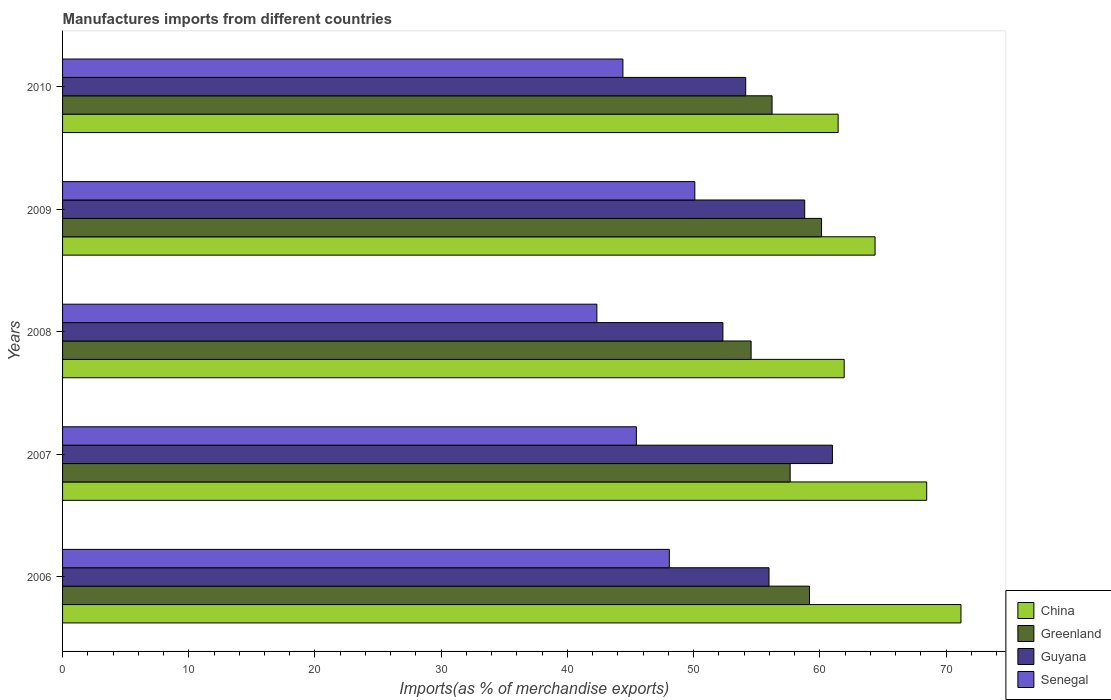How many groups of bars are there?
Keep it short and to the point. 5. Are the number of bars per tick equal to the number of legend labels?
Your answer should be compact. Yes. Are the number of bars on each tick of the Y-axis equal?
Offer a terse response. Yes. How many bars are there on the 5th tick from the top?
Keep it short and to the point. 4. How many bars are there on the 4th tick from the bottom?
Provide a succinct answer. 4. What is the percentage of imports to different countries in Greenland in 2010?
Provide a short and direct response. 56.22. Across all years, what is the maximum percentage of imports to different countries in China?
Your response must be concise. 71.18. Across all years, what is the minimum percentage of imports to different countries in Greenland?
Make the answer very short. 54.56. In which year was the percentage of imports to different countries in Senegal maximum?
Offer a very short reply. 2009. In which year was the percentage of imports to different countries in Greenland minimum?
Your response must be concise. 2008. What is the total percentage of imports to different countries in China in the graph?
Keep it short and to the point. 327.41. What is the difference between the percentage of imports to different countries in Senegal in 2007 and that in 2008?
Offer a terse response. 3.13. What is the difference between the percentage of imports to different countries in Senegal in 2006 and the percentage of imports to different countries in Greenland in 2007?
Provide a succinct answer. -9.57. What is the average percentage of imports to different countries in Guyana per year?
Offer a very short reply. 56.45. In the year 2008, what is the difference between the percentage of imports to different countries in Senegal and percentage of imports to different countries in China?
Your answer should be very brief. -19.6. In how many years, is the percentage of imports to different countries in China greater than 68 %?
Your response must be concise. 2. What is the ratio of the percentage of imports to different countries in Guyana in 2007 to that in 2009?
Your answer should be compact. 1.04. What is the difference between the highest and the second highest percentage of imports to different countries in Guyana?
Provide a succinct answer. 2.2. What is the difference between the highest and the lowest percentage of imports to different countries in China?
Provide a short and direct response. 9.73. In how many years, is the percentage of imports to different countries in Guyana greater than the average percentage of imports to different countries in Guyana taken over all years?
Your response must be concise. 2. Is it the case that in every year, the sum of the percentage of imports to different countries in Senegal and percentage of imports to different countries in China is greater than the sum of percentage of imports to different countries in Greenland and percentage of imports to different countries in Guyana?
Your answer should be compact. No. What does the 3rd bar from the bottom in 2009 represents?
Provide a succinct answer. Guyana. Are all the bars in the graph horizontal?
Your response must be concise. Yes. Does the graph contain any zero values?
Offer a terse response. No. Does the graph contain grids?
Offer a terse response. No. Where does the legend appear in the graph?
Your response must be concise. Bottom right. How many legend labels are there?
Provide a short and direct response. 4. How are the legend labels stacked?
Offer a very short reply. Vertical. What is the title of the graph?
Give a very brief answer. Manufactures imports from different countries. What is the label or title of the X-axis?
Keep it short and to the point. Imports(as % of merchandise exports). What is the Imports(as % of merchandise exports) of China in 2006?
Provide a succinct answer. 71.18. What is the Imports(as % of merchandise exports) of Greenland in 2006?
Keep it short and to the point. 59.18. What is the Imports(as % of merchandise exports) of Guyana in 2006?
Provide a succinct answer. 55.98. What is the Imports(as % of merchandise exports) in Senegal in 2006?
Offer a terse response. 48.08. What is the Imports(as % of merchandise exports) of China in 2007?
Your answer should be compact. 68.47. What is the Imports(as % of merchandise exports) in Greenland in 2007?
Your answer should be compact. 57.65. What is the Imports(as % of merchandise exports) of Guyana in 2007?
Make the answer very short. 61. What is the Imports(as % of merchandise exports) in Senegal in 2007?
Keep it short and to the point. 45.47. What is the Imports(as % of merchandise exports) of China in 2008?
Provide a short and direct response. 61.93. What is the Imports(as % of merchandise exports) of Greenland in 2008?
Provide a short and direct response. 54.56. What is the Imports(as % of merchandise exports) of Guyana in 2008?
Your answer should be very brief. 52.32. What is the Imports(as % of merchandise exports) of Senegal in 2008?
Your answer should be compact. 42.33. What is the Imports(as % of merchandise exports) in China in 2009?
Your response must be concise. 64.38. What is the Imports(as % of merchandise exports) of Greenland in 2009?
Provide a succinct answer. 60.14. What is the Imports(as % of merchandise exports) of Guyana in 2009?
Your response must be concise. 58.8. What is the Imports(as % of merchandise exports) in Senegal in 2009?
Provide a succinct answer. 50.1. What is the Imports(as % of merchandise exports) in China in 2010?
Your answer should be very brief. 61.45. What is the Imports(as % of merchandise exports) in Greenland in 2010?
Provide a short and direct response. 56.22. What is the Imports(as % of merchandise exports) in Guyana in 2010?
Ensure brevity in your answer.  54.13. What is the Imports(as % of merchandise exports) in Senegal in 2010?
Give a very brief answer. 44.4. Across all years, what is the maximum Imports(as % of merchandise exports) of China?
Ensure brevity in your answer.  71.18. Across all years, what is the maximum Imports(as % of merchandise exports) of Greenland?
Keep it short and to the point. 60.14. Across all years, what is the maximum Imports(as % of merchandise exports) in Guyana?
Offer a very short reply. 61. Across all years, what is the maximum Imports(as % of merchandise exports) of Senegal?
Your response must be concise. 50.1. Across all years, what is the minimum Imports(as % of merchandise exports) of China?
Your answer should be very brief. 61.45. Across all years, what is the minimum Imports(as % of merchandise exports) in Greenland?
Your answer should be very brief. 54.56. Across all years, what is the minimum Imports(as % of merchandise exports) of Guyana?
Keep it short and to the point. 52.32. Across all years, what is the minimum Imports(as % of merchandise exports) in Senegal?
Your answer should be very brief. 42.33. What is the total Imports(as % of merchandise exports) of China in the graph?
Offer a terse response. 327.41. What is the total Imports(as % of merchandise exports) in Greenland in the graph?
Offer a terse response. 287.74. What is the total Imports(as % of merchandise exports) of Guyana in the graph?
Ensure brevity in your answer.  282.23. What is the total Imports(as % of merchandise exports) of Senegal in the graph?
Provide a short and direct response. 230.37. What is the difference between the Imports(as % of merchandise exports) of China in 2006 and that in 2007?
Keep it short and to the point. 2.71. What is the difference between the Imports(as % of merchandise exports) in Greenland in 2006 and that in 2007?
Offer a very short reply. 1.53. What is the difference between the Imports(as % of merchandise exports) of Guyana in 2006 and that in 2007?
Offer a very short reply. -5.02. What is the difference between the Imports(as % of merchandise exports) of Senegal in 2006 and that in 2007?
Your response must be concise. 2.61. What is the difference between the Imports(as % of merchandise exports) of China in 2006 and that in 2008?
Give a very brief answer. 9.25. What is the difference between the Imports(as % of merchandise exports) in Greenland in 2006 and that in 2008?
Give a very brief answer. 4.63. What is the difference between the Imports(as % of merchandise exports) in Guyana in 2006 and that in 2008?
Your answer should be compact. 3.65. What is the difference between the Imports(as % of merchandise exports) of Senegal in 2006 and that in 2008?
Give a very brief answer. 5.74. What is the difference between the Imports(as % of merchandise exports) of China in 2006 and that in 2009?
Offer a very short reply. 6.81. What is the difference between the Imports(as % of merchandise exports) in Greenland in 2006 and that in 2009?
Your answer should be very brief. -0.95. What is the difference between the Imports(as % of merchandise exports) in Guyana in 2006 and that in 2009?
Offer a very short reply. -2.83. What is the difference between the Imports(as % of merchandise exports) in Senegal in 2006 and that in 2009?
Provide a succinct answer. -2.02. What is the difference between the Imports(as % of merchandise exports) in China in 2006 and that in 2010?
Offer a very short reply. 9.73. What is the difference between the Imports(as % of merchandise exports) of Greenland in 2006 and that in 2010?
Make the answer very short. 2.97. What is the difference between the Imports(as % of merchandise exports) of Guyana in 2006 and that in 2010?
Offer a very short reply. 1.85. What is the difference between the Imports(as % of merchandise exports) of Senegal in 2006 and that in 2010?
Your answer should be very brief. 3.68. What is the difference between the Imports(as % of merchandise exports) in China in 2007 and that in 2008?
Your answer should be very brief. 6.54. What is the difference between the Imports(as % of merchandise exports) in Greenland in 2007 and that in 2008?
Keep it short and to the point. 3.09. What is the difference between the Imports(as % of merchandise exports) in Guyana in 2007 and that in 2008?
Keep it short and to the point. 8.68. What is the difference between the Imports(as % of merchandise exports) in Senegal in 2007 and that in 2008?
Offer a very short reply. 3.13. What is the difference between the Imports(as % of merchandise exports) in China in 2007 and that in 2009?
Ensure brevity in your answer.  4.09. What is the difference between the Imports(as % of merchandise exports) of Greenland in 2007 and that in 2009?
Offer a terse response. -2.49. What is the difference between the Imports(as % of merchandise exports) in Guyana in 2007 and that in 2009?
Give a very brief answer. 2.2. What is the difference between the Imports(as % of merchandise exports) of Senegal in 2007 and that in 2009?
Offer a very short reply. -4.63. What is the difference between the Imports(as % of merchandise exports) of China in 2007 and that in 2010?
Your answer should be compact. 7.02. What is the difference between the Imports(as % of merchandise exports) of Greenland in 2007 and that in 2010?
Your response must be concise. 1.43. What is the difference between the Imports(as % of merchandise exports) in Guyana in 2007 and that in 2010?
Make the answer very short. 6.87. What is the difference between the Imports(as % of merchandise exports) in Senegal in 2007 and that in 2010?
Keep it short and to the point. 1.07. What is the difference between the Imports(as % of merchandise exports) of China in 2008 and that in 2009?
Give a very brief answer. -2.45. What is the difference between the Imports(as % of merchandise exports) in Greenland in 2008 and that in 2009?
Ensure brevity in your answer.  -5.58. What is the difference between the Imports(as % of merchandise exports) in Guyana in 2008 and that in 2009?
Make the answer very short. -6.48. What is the difference between the Imports(as % of merchandise exports) in Senegal in 2008 and that in 2009?
Provide a short and direct response. -7.76. What is the difference between the Imports(as % of merchandise exports) in China in 2008 and that in 2010?
Provide a succinct answer. 0.48. What is the difference between the Imports(as % of merchandise exports) in Greenland in 2008 and that in 2010?
Make the answer very short. -1.66. What is the difference between the Imports(as % of merchandise exports) in Guyana in 2008 and that in 2010?
Ensure brevity in your answer.  -1.81. What is the difference between the Imports(as % of merchandise exports) of Senegal in 2008 and that in 2010?
Your answer should be compact. -2.06. What is the difference between the Imports(as % of merchandise exports) of China in 2009 and that in 2010?
Provide a short and direct response. 2.93. What is the difference between the Imports(as % of merchandise exports) of Greenland in 2009 and that in 2010?
Offer a very short reply. 3.92. What is the difference between the Imports(as % of merchandise exports) in Guyana in 2009 and that in 2010?
Provide a succinct answer. 4.67. What is the difference between the Imports(as % of merchandise exports) in Senegal in 2009 and that in 2010?
Ensure brevity in your answer.  5.7. What is the difference between the Imports(as % of merchandise exports) of China in 2006 and the Imports(as % of merchandise exports) of Greenland in 2007?
Your response must be concise. 13.53. What is the difference between the Imports(as % of merchandise exports) in China in 2006 and the Imports(as % of merchandise exports) in Guyana in 2007?
Keep it short and to the point. 10.18. What is the difference between the Imports(as % of merchandise exports) of China in 2006 and the Imports(as % of merchandise exports) of Senegal in 2007?
Your answer should be very brief. 25.72. What is the difference between the Imports(as % of merchandise exports) in Greenland in 2006 and the Imports(as % of merchandise exports) in Guyana in 2007?
Your response must be concise. -1.82. What is the difference between the Imports(as % of merchandise exports) of Greenland in 2006 and the Imports(as % of merchandise exports) of Senegal in 2007?
Provide a succinct answer. 13.72. What is the difference between the Imports(as % of merchandise exports) in Guyana in 2006 and the Imports(as % of merchandise exports) in Senegal in 2007?
Your answer should be compact. 10.51. What is the difference between the Imports(as % of merchandise exports) of China in 2006 and the Imports(as % of merchandise exports) of Greenland in 2008?
Provide a succinct answer. 16.63. What is the difference between the Imports(as % of merchandise exports) in China in 2006 and the Imports(as % of merchandise exports) in Guyana in 2008?
Your answer should be very brief. 18.86. What is the difference between the Imports(as % of merchandise exports) in China in 2006 and the Imports(as % of merchandise exports) in Senegal in 2008?
Offer a very short reply. 28.85. What is the difference between the Imports(as % of merchandise exports) of Greenland in 2006 and the Imports(as % of merchandise exports) of Guyana in 2008?
Your response must be concise. 6.86. What is the difference between the Imports(as % of merchandise exports) in Greenland in 2006 and the Imports(as % of merchandise exports) in Senegal in 2008?
Your response must be concise. 16.85. What is the difference between the Imports(as % of merchandise exports) in Guyana in 2006 and the Imports(as % of merchandise exports) in Senegal in 2008?
Ensure brevity in your answer.  13.64. What is the difference between the Imports(as % of merchandise exports) of China in 2006 and the Imports(as % of merchandise exports) of Greenland in 2009?
Offer a very short reply. 11.05. What is the difference between the Imports(as % of merchandise exports) of China in 2006 and the Imports(as % of merchandise exports) of Guyana in 2009?
Offer a terse response. 12.38. What is the difference between the Imports(as % of merchandise exports) in China in 2006 and the Imports(as % of merchandise exports) in Senegal in 2009?
Your response must be concise. 21.09. What is the difference between the Imports(as % of merchandise exports) in Greenland in 2006 and the Imports(as % of merchandise exports) in Guyana in 2009?
Your answer should be compact. 0.38. What is the difference between the Imports(as % of merchandise exports) in Greenland in 2006 and the Imports(as % of merchandise exports) in Senegal in 2009?
Offer a terse response. 9.09. What is the difference between the Imports(as % of merchandise exports) of Guyana in 2006 and the Imports(as % of merchandise exports) of Senegal in 2009?
Provide a short and direct response. 5.88. What is the difference between the Imports(as % of merchandise exports) of China in 2006 and the Imports(as % of merchandise exports) of Greenland in 2010?
Provide a short and direct response. 14.97. What is the difference between the Imports(as % of merchandise exports) in China in 2006 and the Imports(as % of merchandise exports) in Guyana in 2010?
Offer a terse response. 17.05. What is the difference between the Imports(as % of merchandise exports) in China in 2006 and the Imports(as % of merchandise exports) in Senegal in 2010?
Provide a short and direct response. 26.78. What is the difference between the Imports(as % of merchandise exports) of Greenland in 2006 and the Imports(as % of merchandise exports) of Guyana in 2010?
Make the answer very short. 5.05. What is the difference between the Imports(as % of merchandise exports) of Greenland in 2006 and the Imports(as % of merchandise exports) of Senegal in 2010?
Offer a very short reply. 14.78. What is the difference between the Imports(as % of merchandise exports) in Guyana in 2006 and the Imports(as % of merchandise exports) in Senegal in 2010?
Your response must be concise. 11.58. What is the difference between the Imports(as % of merchandise exports) in China in 2007 and the Imports(as % of merchandise exports) in Greenland in 2008?
Provide a short and direct response. 13.91. What is the difference between the Imports(as % of merchandise exports) of China in 2007 and the Imports(as % of merchandise exports) of Guyana in 2008?
Give a very brief answer. 16.15. What is the difference between the Imports(as % of merchandise exports) in China in 2007 and the Imports(as % of merchandise exports) in Senegal in 2008?
Provide a succinct answer. 26.13. What is the difference between the Imports(as % of merchandise exports) of Greenland in 2007 and the Imports(as % of merchandise exports) of Guyana in 2008?
Provide a short and direct response. 5.33. What is the difference between the Imports(as % of merchandise exports) of Greenland in 2007 and the Imports(as % of merchandise exports) of Senegal in 2008?
Keep it short and to the point. 15.32. What is the difference between the Imports(as % of merchandise exports) in Guyana in 2007 and the Imports(as % of merchandise exports) in Senegal in 2008?
Your answer should be very brief. 18.66. What is the difference between the Imports(as % of merchandise exports) of China in 2007 and the Imports(as % of merchandise exports) of Greenland in 2009?
Keep it short and to the point. 8.33. What is the difference between the Imports(as % of merchandise exports) in China in 2007 and the Imports(as % of merchandise exports) in Guyana in 2009?
Your response must be concise. 9.67. What is the difference between the Imports(as % of merchandise exports) of China in 2007 and the Imports(as % of merchandise exports) of Senegal in 2009?
Provide a succinct answer. 18.37. What is the difference between the Imports(as % of merchandise exports) in Greenland in 2007 and the Imports(as % of merchandise exports) in Guyana in 2009?
Provide a succinct answer. -1.15. What is the difference between the Imports(as % of merchandise exports) in Greenland in 2007 and the Imports(as % of merchandise exports) in Senegal in 2009?
Your answer should be compact. 7.55. What is the difference between the Imports(as % of merchandise exports) in Guyana in 2007 and the Imports(as % of merchandise exports) in Senegal in 2009?
Your response must be concise. 10.9. What is the difference between the Imports(as % of merchandise exports) of China in 2007 and the Imports(as % of merchandise exports) of Greenland in 2010?
Your answer should be very brief. 12.25. What is the difference between the Imports(as % of merchandise exports) of China in 2007 and the Imports(as % of merchandise exports) of Guyana in 2010?
Offer a very short reply. 14.34. What is the difference between the Imports(as % of merchandise exports) in China in 2007 and the Imports(as % of merchandise exports) in Senegal in 2010?
Keep it short and to the point. 24.07. What is the difference between the Imports(as % of merchandise exports) of Greenland in 2007 and the Imports(as % of merchandise exports) of Guyana in 2010?
Give a very brief answer. 3.52. What is the difference between the Imports(as % of merchandise exports) of Greenland in 2007 and the Imports(as % of merchandise exports) of Senegal in 2010?
Provide a succinct answer. 13.25. What is the difference between the Imports(as % of merchandise exports) in Guyana in 2007 and the Imports(as % of merchandise exports) in Senegal in 2010?
Offer a terse response. 16.6. What is the difference between the Imports(as % of merchandise exports) of China in 2008 and the Imports(as % of merchandise exports) of Greenland in 2009?
Offer a terse response. 1.79. What is the difference between the Imports(as % of merchandise exports) of China in 2008 and the Imports(as % of merchandise exports) of Guyana in 2009?
Keep it short and to the point. 3.13. What is the difference between the Imports(as % of merchandise exports) in China in 2008 and the Imports(as % of merchandise exports) in Senegal in 2009?
Provide a short and direct response. 11.83. What is the difference between the Imports(as % of merchandise exports) of Greenland in 2008 and the Imports(as % of merchandise exports) of Guyana in 2009?
Offer a very short reply. -4.25. What is the difference between the Imports(as % of merchandise exports) in Greenland in 2008 and the Imports(as % of merchandise exports) in Senegal in 2009?
Offer a very short reply. 4.46. What is the difference between the Imports(as % of merchandise exports) in Guyana in 2008 and the Imports(as % of merchandise exports) in Senegal in 2009?
Give a very brief answer. 2.22. What is the difference between the Imports(as % of merchandise exports) of China in 2008 and the Imports(as % of merchandise exports) of Greenland in 2010?
Provide a short and direct response. 5.71. What is the difference between the Imports(as % of merchandise exports) of China in 2008 and the Imports(as % of merchandise exports) of Guyana in 2010?
Your response must be concise. 7.8. What is the difference between the Imports(as % of merchandise exports) in China in 2008 and the Imports(as % of merchandise exports) in Senegal in 2010?
Offer a terse response. 17.53. What is the difference between the Imports(as % of merchandise exports) in Greenland in 2008 and the Imports(as % of merchandise exports) in Guyana in 2010?
Your answer should be very brief. 0.43. What is the difference between the Imports(as % of merchandise exports) of Greenland in 2008 and the Imports(as % of merchandise exports) of Senegal in 2010?
Your answer should be very brief. 10.16. What is the difference between the Imports(as % of merchandise exports) of Guyana in 2008 and the Imports(as % of merchandise exports) of Senegal in 2010?
Your answer should be compact. 7.92. What is the difference between the Imports(as % of merchandise exports) of China in 2009 and the Imports(as % of merchandise exports) of Greenland in 2010?
Your answer should be compact. 8.16. What is the difference between the Imports(as % of merchandise exports) in China in 2009 and the Imports(as % of merchandise exports) in Guyana in 2010?
Your answer should be very brief. 10.25. What is the difference between the Imports(as % of merchandise exports) of China in 2009 and the Imports(as % of merchandise exports) of Senegal in 2010?
Offer a terse response. 19.98. What is the difference between the Imports(as % of merchandise exports) in Greenland in 2009 and the Imports(as % of merchandise exports) in Guyana in 2010?
Your answer should be very brief. 6.01. What is the difference between the Imports(as % of merchandise exports) of Greenland in 2009 and the Imports(as % of merchandise exports) of Senegal in 2010?
Offer a terse response. 15.74. What is the difference between the Imports(as % of merchandise exports) in Guyana in 2009 and the Imports(as % of merchandise exports) in Senegal in 2010?
Offer a very short reply. 14.4. What is the average Imports(as % of merchandise exports) in China per year?
Keep it short and to the point. 65.48. What is the average Imports(as % of merchandise exports) of Greenland per year?
Give a very brief answer. 57.55. What is the average Imports(as % of merchandise exports) of Guyana per year?
Keep it short and to the point. 56.45. What is the average Imports(as % of merchandise exports) of Senegal per year?
Your answer should be compact. 46.07. In the year 2006, what is the difference between the Imports(as % of merchandise exports) of China and Imports(as % of merchandise exports) of Greenland?
Make the answer very short. 12. In the year 2006, what is the difference between the Imports(as % of merchandise exports) in China and Imports(as % of merchandise exports) in Guyana?
Ensure brevity in your answer.  15.21. In the year 2006, what is the difference between the Imports(as % of merchandise exports) in China and Imports(as % of merchandise exports) in Senegal?
Your answer should be very brief. 23.11. In the year 2006, what is the difference between the Imports(as % of merchandise exports) in Greenland and Imports(as % of merchandise exports) in Guyana?
Give a very brief answer. 3.21. In the year 2006, what is the difference between the Imports(as % of merchandise exports) in Greenland and Imports(as % of merchandise exports) in Senegal?
Give a very brief answer. 11.11. In the year 2006, what is the difference between the Imports(as % of merchandise exports) in Guyana and Imports(as % of merchandise exports) in Senegal?
Give a very brief answer. 7.9. In the year 2007, what is the difference between the Imports(as % of merchandise exports) in China and Imports(as % of merchandise exports) in Greenland?
Give a very brief answer. 10.82. In the year 2007, what is the difference between the Imports(as % of merchandise exports) in China and Imports(as % of merchandise exports) in Guyana?
Give a very brief answer. 7.47. In the year 2007, what is the difference between the Imports(as % of merchandise exports) of China and Imports(as % of merchandise exports) of Senegal?
Give a very brief answer. 23. In the year 2007, what is the difference between the Imports(as % of merchandise exports) in Greenland and Imports(as % of merchandise exports) in Guyana?
Offer a terse response. -3.35. In the year 2007, what is the difference between the Imports(as % of merchandise exports) of Greenland and Imports(as % of merchandise exports) of Senegal?
Your response must be concise. 12.18. In the year 2007, what is the difference between the Imports(as % of merchandise exports) in Guyana and Imports(as % of merchandise exports) in Senegal?
Your answer should be very brief. 15.53. In the year 2008, what is the difference between the Imports(as % of merchandise exports) of China and Imports(as % of merchandise exports) of Greenland?
Make the answer very short. 7.37. In the year 2008, what is the difference between the Imports(as % of merchandise exports) in China and Imports(as % of merchandise exports) in Guyana?
Offer a terse response. 9.61. In the year 2008, what is the difference between the Imports(as % of merchandise exports) of China and Imports(as % of merchandise exports) of Senegal?
Your answer should be compact. 19.6. In the year 2008, what is the difference between the Imports(as % of merchandise exports) in Greenland and Imports(as % of merchandise exports) in Guyana?
Provide a short and direct response. 2.23. In the year 2008, what is the difference between the Imports(as % of merchandise exports) in Greenland and Imports(as % of merchandise exports) in Senegal?
Your response must be concise. 12.22. In the year 2008, what is the difference between the Imports(as % of merchandise exports) of Guyana and Imports(as % of merchandise exports) of Senegal?
Give a very brief answer. 9.99. In the year 2009, what is the difference between the Imports(as % of merchandise exports) of China and Imports(as % of merchandise exports) of Greenland?
Keep it short and to the point. 4.24. In the year 2009, what is the difference between the Imports(as % of merchandise exports) of China and Imports(as % of merchandise exports) of Guyana?
Your response must be concise. 5.57. In the year 2009, what is the difference between the Imports(as % of merchandise exports) in China and Imports(as % of merchandise exports) in Senegal?
Your answer should be very brief. 14.28. In the year 2009, what is the difference between the Imports(as % of merchandise exports) in Greenland and Imports(as % of merchandise exports) in Guyana?
Provide a short and direct response. 1.33. In the year 2009, what is the difference between the Imports(as % of merchandise exports) of Greenland and Imports(as % of merchandise exports) of Senegal?
Offer a terse response. 10.04. In the year 2009, what is the difference between the Imports(as % of merchandise exports) in Guyana and Imports(as % of merchandise exports) in Senegal?
Your response must be concise. 8.71. In the year 2010, what is the difference between the Imports(as % of merchandise exports) in China and Imports(as % of merchandise exports) in Greenland?
Provide a succinct answer. 5.23. In the year 2010, what is the difference between the Imports(as % of merchandise exports) of China and Imports(as % of merchandise exports) of Guyana?
Offer a very short reply. 7.32. In the year 2010, what is the difference between the Imports(as % of merchandise exports) in China and Imports(as % of merchandise exports) in Senegal?
Provide a short and direct response. 17.05. In the year 2010, what is the difference between the Imports(as % of merchandise exports) of Greenland and Imports(as % of merchandise exports) of Guyana?
Make the answer very short. 2.09. In the year 2010, what is the difference between the Imports(as % of merchandise exports) of Greenland and Imports(as % of merchandise exports) of Senegal?
Give a very brief answer. 11.82. In the year 2010, what is the difference between the Imports(as % of merchandise exports) of Guyana and Imports(as % of merchandise exports) of Senegal?
Ensure brevity in your answer.  9.73. What is the ratio of the Imports(as % of merchandise exports) in China in 2006 to that in 2007?
Provide a short and direct response. 1.04. What is the ratio of the Imports(as % of merchandise exports) in Greenland in 2006 to that in 2007?
Offer a very short reply. 1.03. What is the ratio of the Imports(as % of merchandise exports) of Guyana in 2006 to that in 2007?
Your response must be concise. 0.92. What is the ratio of the Imports(as % of merchandise exports) in Senegal in 2006 to that in 2007?
Ensure brevity in your answer.  1.06. What is the ratio of the Imports(as % of merchandise exports) in China in 2006 to that in 2008?
Make the answer very short. 1.15. What is the ratio of the Imports(as % of merchandise exports) of Greenland in 2006 to that in 2008?
Offer a very short reply. 1.08. What is the ratio of the Imports(as % of merchandise exports) in Guyana in 2006 to that in 2008?
Keep it short and to the point. 1.07. What is the ratio of the Imports(as % of merchandise exports) of Senegal in 2006 to that in 2008?
Make the answer very short. 1.14. What is the ratio of the Imports(as % of merchandise exports) of China in 2006 to that in 2009?
Ensure brevity in your answer.  1.11. What is the ratio of the Imports(as % of merchandise exports) in Greenland in 2006 to that in 2009?
Offer a terse response. 0.98. What is the ratio of the Imports(as % of merchandise exports) in Guyana in 2006 to that in 2009?
Provide a short and direct response. 0.95. What is the ratio of the Imports(as % of merchandise exports) in Senegal in 2006 to that in 2009?
Offer a terse response. 0.96. What is the ratio of the Imports(as % of merchandise exports) of China in 2006 to that in 2010?
Keep it short and to the point. 1.16. What is the ratio of the Imports(as % of merchandise exports) of Greenland in 2006 to that in 2010?
Offer a very short reply. 1.05. What is the ratio of the Imports(as % of merchandise exports) of Guyana in 2006 to that in 2010?
Ensure brevity in your answer.  1.03. What is the ratio of the Imports(as % of merchandise exports) of Senegal in 2006 to that in 2010?
Your response must be concise. 1.08. What is the ratio of the Imports(as % of merchandise exports) in China in 2007 to that in 2008?
Give a very brief answer. 1.11. What is the ratio of the Imports(as % of merchandise exports) of Greenland in 2007 to that in 2008?
Offer a terse response. 1.06. What is the ratio of the Imports(as % of merchandise exports) in Guyana in 2007 to that in 2008?
Offer a terse response. 1.17. What is the ratio of the Imports(as % of merchandise exports) in Senegal in 2007 to that in 2008?
Give a very brief answer. 1.07. What is the ratio of the Imports(as % of merchandise exports) in China in 2007 to that in 2009?
Your answer should be very brief. 1.06. What is the ratio of the Imports(as % of merchandise exports) in Greenland in 2007 to that in 2009?
Keep it short and to the point. 0.96. What is the ratio of the Imports(as % of merchandise exports) in Guyana in 2007 to that in 2009?
Your answer should be compact. 1.04. What is the ratio of the Imports(as % of merchandise exports) of Senegal in 2007 to that in 2009?
Provide a succinct answer. 0.91. What is the ratio of the Imports(as % of merchandise exports) of China in 2007 to that in 2010?
Offer a terse response. 1.11. What is the ratio of the Imports(as % of merchandise exports) of Greenland in 2007 to that in 2010?
Offer a terse response. 1.03. What is the ratio of the Imports(as % of merchandise exports) of Guyana in 2007 to that in 2010?
Make the answer very short. 1.13. What is the ratio of the Imports(as % of merchandise exports) in Senegal in 2007 to that in 2010?
Your response must be concise. 1.02. What is the ratio of the Imports(as % of merchandise exports) of Greenland in 2008 to that in 2009?
Give a very brief answer. 0.91. What is the ratio of the Imports(as % of merchandise exports) in Guyana in 2008 to that in 2009?
Offer a very short reply. 0.89. What is the ratio of the Imports(as % of merchandise exports) of Senegal in 2008 to that in 2009?
Keep it short and to the point. 0.85. What is the ratio of the Imports(as % of merchandise exports) in Greenland in 2008 to that in 2010?
Ensure brevity in your answer.  0.97. What is the ratio of the Imports(as % of merchandise exports) in Guyana in 2008 to that in 2010?
Your response must be concise. 0.97. What is the ratio of the Imports(as % of merchandise exports) in Senegal in 2008 to that in 2010?
Your answer should be compact. 0.95. What is the ratio of the Imports(as % of merchandise exports) in China in 2009 to that in 2010?
Your answer should be very brief. 1.05. What is the ratio of the Imports(as % of merchandise exports) in Greenland in 2009 to that in 2010?
Your response must be concise. 1.07. What is the ratio of the Imports(as % of merchandise exports) in Guyana in 2009 to that in 2010?
Your answer should be very brief. 1.09. What is the ratio of the Imports(as % of merchandise exports) of Senegal in 2009 to that in 2010?
Your answer should be compact. 1.13. What is the difference between the highest and the second highest Imports(as % of merchandise exports) in China?
Offer a terse response. 2.71. What is the difference between the highest and the second highest Imports(as % of merchandise exports) in Greenland?
Give a very brief answer. 0.95. What is the difference between the highest and the second highest Imports(as % of merchandise exports) of Guyana?
Your answer should be compact. 2.2. What is the difference between the highest and the second highest Imports(as % of merchandise exports) in Senegal?
Your answer should be very brief. 2.02. What is the difference between the highest and the lowest Imports(as % of merchandise exports) in China?
Offer a very short reply. 9.73. What is the difference between the highest and the lowest Imports(as % of merchandise exports) of Greenland?
Your answer should be compact. 5.58. What is the difference between the highest and the lowest Imports(as % of merchandise exports) of Guyana?
Your answer should be very brief. 8.68. What is the difference between the highest and the lowest Imports(as % of merchandise exports) of Senegal?
Keep it short and to the point. 7.76. 